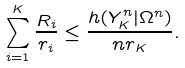Convert formula to latex. <formula><loc_0><loc_0><loc_500><loc_500>\sum _ { i = 1 } ^ { K } \frac { R _ { i } } { r _ { i } } \leq \frac { h ( Y _ { K } ^ { n } | \Omega ^ { n } ) } { n r _ { K } } .</formula> 